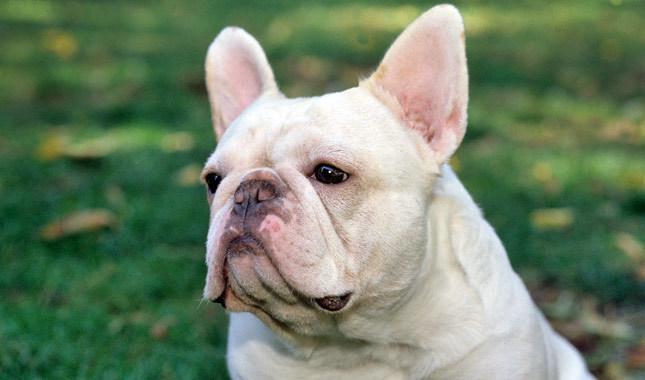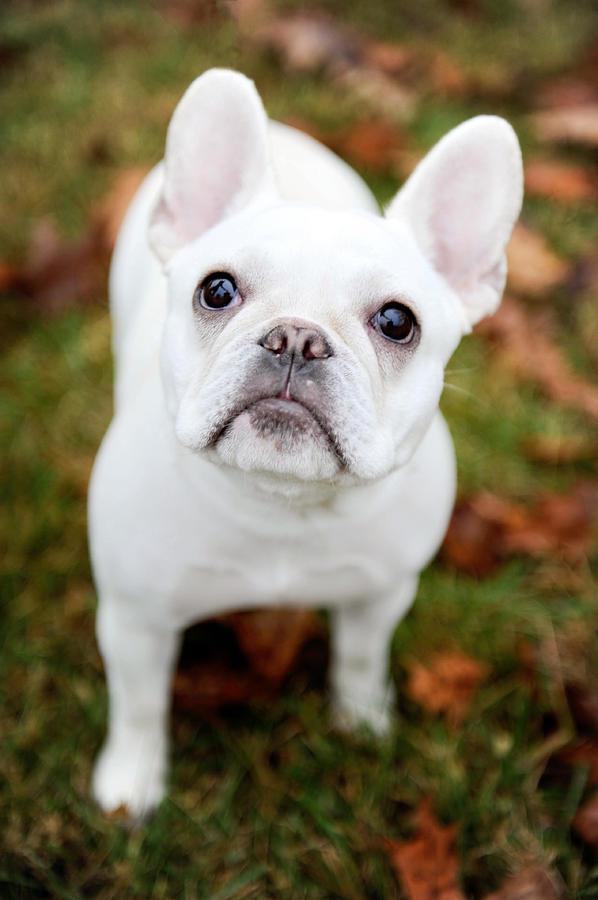The first image is the image on the left, the second image is the image on the right. Examine the images to the left and right. Is the description "At least one dog has black fur on an ear." accurate? Answer yes or no. No. 